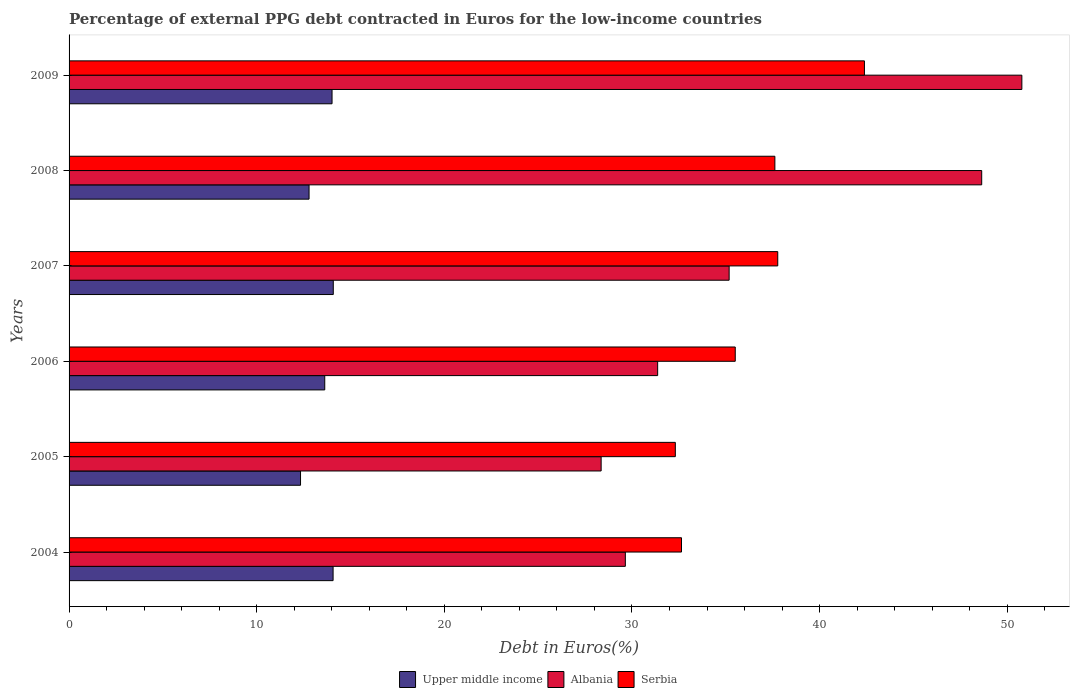Are the number of bars per tick equal to the number of legend labels?
Give a very brief answer. Yes. How many bars are there on the 4th tick from the top?
Your answer should be very brief. 3. What is the label of the 1st group of bars from the top?
Your answer should be compact. 2009. In how many cases, is the number of bars for a given year not equal to the number of legend labels?
Ensure brevity in your answer.  0. What is the percentage of external PPG debt contracted in Euros in Serbia in 2006?
Ensure brevity in your answer.  35.5. Across all years, what is the maximum percentage of external PPG debt contracted in Euros in Upper middle income?
Your answer should be compact. 14.08. Across all years, what is the minimum percentage of external PPG debt contracted in Euros in Albania?
Ensure brevity in your answer.  28.36. What is the total percentage of external PPG debt contracted in Euros in Serbia in the graph?
Provide a short and direct response. 218.23. What is the difference between the percentage of external PPG debt contracted in Euros in Serbia in 2006 and that in 2009?
Make the answer very short. -6.88. What is the difference between the percentage of external PPG debt contracted in Euros in Serbia in 2004 and the percentage of external PPG debt contracted in Euros in Albania in 2009?
Offer a terse response. -18.14. What is the average percentage of external PPG debt contracted in Euros in Upper middle income per year?
Provide a succinct answer. 13.49. In the year 2007, what is the difference between the percentage of external PPG debt contracted in Euros in Upper middle income and percentage of external PPG debt contracted in Euros in Serbia?
Give a very brief answer. -23.69. What is the ratio of the percentage of external PPG debt contracted in Euros in Albania in 2005 to that in 2009?
Provide a succinct answer. 0.56. Is the percentage of external PPG debt contracted in Euros in Upper middle income in 2005 less than that in 2006?
Your response must be concise. Yes. Is the difference between the percentage of external PPG debt contracted in Euros in Upper middle income in 2004 and 2009 greater than the difference between the percentage of external PPG debt contracted in Euros in Serbia in 2004 and 2009?
Offer a very short reply. Yes. What is the difference between the highest and the second highest percentage of external PPG debt contracted in Euros in Serbia?
Your response must be concise. 4.62. What is the difference between the highest and the lowest percentage of external PPG debt contracted in Euros in Upper middle income?
Your answer should be compact. 1.74. Is the sum of the percentage of external PPG debt contracted in Euros in Serbia in 2004 and 2009 greater than the maximum percentage of external PPG debt contracted in Euros in Albania across all years?
Offer a terse response. Yes. What does the 1st bar from the top in 2005 represents?
Your answer should be very brief. Serbia. What does the 2nd bar from the bottom in 2009 represents?
Your answer should be very brief. Albania. How many years are there in the graph?
Give a very brief answer. 6. Does the graph contain any zero values?
Your answer should be very brief. No. Does the graph contain grids?
Give a very brief answer. No. What is the title of the graph?
Give a very brief answer. Percentage of external PPG debt contracted in Euros for the low-income countries. Does "Chad" appear as one of the legend labels in the graph?
Provide a succinct answer. No. What is the label or title of the X-axis?
Make the answer very short. Debt in Euros(%). What is the Debt in Euros(%) in Upper middle income in 2004?
Your answer should be very brief. 14.07. What is the Debt in Euros(%) of Albania in 2004?
Provide a succinct answer. 29.65. What is the Debt in Euros(%) in Serbia in 2004?
Your response must be concise. 32.64. What is the Debt in Euros(%) of Upper middle income in 2005?
Offer a very short reply. 12.34. What is the Debt in Euros(%) of Albania in 2005?
Offer a terse response. 28.36. What is the Debt in Euros(%) in Serbia in 2005?
Your answer should be very brief. 32.31. What is the Debt in Euros(%) of Upper middle income in 2006?
Provide a short and direct response. 13.63. What is the Debt in Euros(%) in Albania in 2006?
Offer a terse response. 31.37. What is the Debt in Euros(%) in Serbia in 2006?
Your answer should be very brief. 35.5. What is the Debt in Euros(%) in Upper middle income in 2007?
Offer a terse response. 14.08. What is the Debt in Euros(%) in Albania in 2007?
Ensure brevity in your answer.  35.18. What is the Debt in Euros(%) of Serbia in 2007?
Provide a short and direct response. 37.77. What is the Debt in Euros(%) in Upper middle income in 2008?
Give a very brief answer. 12.79. What is the Debt in Euros(%) of Albania in 2008?
Offer a very short reply. 48.64. What is the Debt in Euros(%) in Serbia in 2008?
Provide a succinct answer. 37.62. What is the Debt in Euros(%) in Upper middle income in 2009?
Offer a terse response. 14.02. What is the Debt in Euros(%) in Albania in 2009?
Ensure brevity in your answer.  50.78. What is the Debt in Euros(%) in Serbia in 2009?
Make the answer very short. 42.39. Across all years, what is the maximum Debt in Euros(%) of Upper middle income?
Offer a terse response. 14.08. Across all years, what is the maximum Debt in Euros(%) of Albania?
Give a very brief answer. 50.78. Across all years, what is the maximum Debt in Euros(%) of Serbia?
Your response must be concise. 42.39. Across all years, what is the minimum Debt in Euros(%) in Upper middle income?
Make the answer very short. 12.34. Across all years, what is the minimum Debt in Euros(%) in Albania?
Provide a short and direct response. 28.36. Across all years, what is the minimum Debt in Euros(%) in Serbia?
Your answer should be very brief. 32.31. What is the total Debt in Euros(%) of Upper middle income in the graph?
Your response must be concise. 80.92. What is the total Debt in Euros(%) in Albania in the graph?
Give a very brief answer. 223.97. What is the total Debt in Euros(%) in Serbia in the graph?
Your answer should be compact. 218.23. What is the difference between the Debt in Euros(%) of Upper middle income in 2004 and that in 2005?
Make the answer very short. 1.74. What is the difference between the Debt in Euros(%) in Albania in 2004 and that in 2005?
Give a very brief answer. 1.29. What is the difference between the Debt in Euros(%) of Serbia in 2004 and that in 2005?
Your answer should be compact. 0.33. What is the difference between the Debt in Euros(%) in Upper middle income in 2004 and that in 2006?
Provide a short and direct response. 0.44. What is the difference between the Debt in Euros(%) in Albania in 2004 and that in 2006?
Your answer should be compact. -1.72. What is the difference between the Debt in Euros(%) in Serbia in 2004 and that in 2006?
Ensure brevity in your answer.  -2.86. What is the difference between the Debt in Euros(%) in Upper middle income in 2004 and that in 2007?
Make the answer very short. -0.01. What is the difference between the Debt in Euros(%) of Albania in 2004 and that in 2007?
Your response must be concise. -5.53. What is the difference between the Debt in Euros(%) of Serbia in 2004 and that in 2007?
Offer a terse response. -5.13. What is the difference between the Debt in Euros(%) in Upper middle income in 2004 and that in 2008?
Your answer should be very brief. 1.28. What is the difference between the Debt in Euros(%) in Albania in 2004 and that in 2008?
Your answer should be very brief. -18.99. What is the difference between the Debt in Euros(%) in Serbia in 2004 and that in 2008?
Offer a very short reply. -4.98. What is the difference between the Debt in Euros(%) of Upper middle income in 2004 and that in 2009?
Your answer should be compact. 0.06. What is the difference between the Debt in Euros(%) in Albania in 2004 and that in 2009?
Offer a terse response. -21.13. What is the difference between the Debt in Euros(%) of Serbia in 2004 and that in 2009?
Offer a very short reply. -9.75. What is the difference between the Debt in Euros(%) of Upper middle income in 2005 and that in 2006?
Provide a short and direct response. -1.29. What is the difference between the Debt in Euros(%) of Albania in 2005 and that in 2006?
Your answer should be very brief. -3.01. What is the difference between the Debt in Euros(%) in Serbia in 2005 and that in 2006?
Provide a short and direct response. -3.19. What is the difference between the Debt in Euros(%) in Upper middle income in 2005 and that in 2007?
Provide a short and direct response. -1.74. What is the difference between the Debt in Euros(%) of Albania in 2005 and that in 2007?
Keep it short and to the point. -6.82. What is the difference between the Debt in Euros(%) of Serbia in 2005 and that in 2007?
Your answer should be very brief. -5.46. What is the difference between the Debt in Euros(%) of Upper middle income in 2005 and that in 2008?
Your response must be concise. -0.45. What is the difference between the Debt in Euros(%) of Albania in 2005 and that in 2008?
Your answer should be compact. -20.28. What is the difference between the Debt in Euros(%) of Serbia in 2005 and that in 2008?
Ensure brevity in your answer.  -5.31. What is the difference between the Debt in Euros(%) in Upper middle income in 2005 and that in 2009?
Your answer should be very brief. -1.68. What is the difference between the Debt in Euros(%) of Albania in 2005 and that in 2009?
Your answer should be compact. -22.42. What is the difference between the Debt in Euros(%) of Serbia in 2005 and that in 2009?
Ensure brevity in your answer.  -10.08. What is the difference between the Debt in Euros(%) of Upper middle income in 2006 and that in 2007?
Offer a very short reply. -0.45. What is the difference between the Debt in Euros(%) of Albania in 2006 and that in 2007?
Keep it short and to the point. -3.81. What is the difference between the Debt in Euros(%) of Serbia in 2006 and that in 2007?
Offer a very short reply. -2.27. What is the difference between the Debt in Euros(%) of Upper middle income in 2006 and that in 2008?
Your answer should be compact. 0.84. What is the difference between the Debt in Euros(%) in Albania in 2006 and that in 2008?
Your response must be concise. -17.27. What is the difference between the Debt in Euros(%) in Serbia in 2006 and that in 2008?
Provide a succinct answer. -2.11. What is the difference between the Debt in Euros(%) of Upper middle income in 2006 and that in 2009?
Provide a succinct answer. -0.39. What is the difference between the Debt in Euros(%) in Albania in 2006 and that in 2009?
Give a very brief answer. -19.41. What is the difference between the Debt in Euros(%) in Serbia in 2006 and that in 2009?
Your answer should be very brief. -6.88. What is the difference between the Debt in Euros(%) of Upper middle income in 2007 and that in 2008?
Your response must be concise. 1.29. What is the difference between the Debt in Euros(%) in Albania in 2007 and that in 2008?
Ensure brevity in your answer.  -13.46. What is the difference between the Debt in Euros(%) of Serbia in 2007 and that in 2008?
Make the answer very short. 0.15. What is the difference between the Debt in Euros(%) of Upper middle income in 2007 and that in 2009?
Ensure brevity in your answer.  0.07. What is the difference between the Debt in Euros(%) of Albania in 2007 and that in 2009?
Your answer should be very brief. -15.6. What is the difference between the Debt in Euros(%) in Serbia in 2007 and that in 2009?
Your response must be concise. -4.62. What is the difference between the Debt in Euros(%) in Upper middle income in 2008 and that in 2009?
Offer a terse response. -1.23. What is the difference between the Debt in Euros(%) in Albania in 2008 and that in 2009?
Your answer should be compact. -2.14. What is the difference between the Debt in Euros(%) of Serbia in 2008 and that in 2009?
Your answer should be compact. -4.77. What is the difference between the Debt in Euros(%) of Upper middle income in 2004 and the Debt in Euros(%) of Albania in 2005?
Your response must be concise. -14.29. What is the difference between the Debt in Euros(%) in Upper middle income in 2004 and the Debt in Euros(%) in Serbia in 2005?
Your response must be concise. -18.24. What is the difference between the Debt in Euros(%) of Albania in 2004 and the Debt in Euros(%) of Serbia in 2005?
Give a very brief answer. -2.66. What is the difference between the Debt in Euros(%) in Upper middle income in 2004 and the Debt in Euros(%) in Albania in 2006?
Give a very brief answer. -17.3. What is the difference between the Debt in Euros(%) of Upper middle income in 2004 and the Debt in Euros(%) of Serbia in 2006?
Provide a succinct answer. -21.43. What is the difference between the Debt in Euros(%) of Albania in 2004 and the Debt in Euros(%) of Serbia in 2006?
Make the answer very short. -5.86. What is the difference between the Debt in Euros(%) of Upper middle income in 2004 and the Debt in Euros(%) of Albania in 2007?
Your answer should be very brief. -21.11. What is the difference between the Debt in Euros(%) of Upper middle income in 2004 and the Debt in Euros(%) of Serbia in 2007?
Keep it short and to the point. -23.7. What is the difference between the Debt in Euros(%) in Albania in 2004 and the Debt in Euros(%) in Serbia in 2007?
Give a very brief answer. -8.12. What is the difference between the Debt in Euros(%) of Upper middle income in 2004 and the Debt in Euros(%) of Albania in 2008?
Provide a short and direct response. -34.57. What is the difference between the Debt in Euros(%) in Upper middle income in 2004 and the Debt in Euros(%) in Serbia in 2008?
Your answer should be compact. -23.55. What is the difference between the Debt in Euros(%) in Albania in 2004 and the Debt in Euros(%) in Serbia in 2008?
Give a very brief answer. -7.97. What is the difference between the Debt in Euros(%) of Upper middle income in 2004 and the Debt in Euros(%) of Albania in 2009?
Your answer should be very brief. -36.71. What is the difference between the Debt in Euros(%) in Upper middle income in 2004 and the Debt in Euros(%) in Serbia in 2009?
Keep it short and to the point. -28.32. What is the difference between the Debt in Euros(%) of Albania in 2004 and the Debt in Euros(%) of Serbia in 2009?
Your response must be concise. -12.74. What is the difference between the Debt in Euros(%) in Upper middle income in 2005 and the Debt in Euros(%) in Albania in 2006?
Your answer should be compact. -19.03. What is the difference between the Debt in Euros(%) in Upper middle income in 2005 and the Debt in Euros(%) in Serbia in 2006?
Make the answer very short. -23.17. What is the difference between the Debt in Euros(%) in Albania in 2005 and the Debt in Euros(%) in Serbia in 2006?
Provide a succinct answer. -7.15. What is the difference between the Debt in Euros(%) in Upper middle income in 2005 and the Debt in Euros(%) in Albania in 2007?
Offer a very short reply. -22.84. What is the difference between the Debt in Euros(%) of Upper middle income in 2005 and the Debt in Euros(%) of Serbia in 2007?
Your answer should be compact. -25.43. What is the difference between the Debt in Euros(%) in Albania in 2005 and the Debt in Euros(%) in Serbia in 2007?
Provide a succinct answer. -9.41. What is the difference between the Debt in Euros(%) in Upper middle income in 2005 and the Debt in Euros(%) in Albania in 2008?
Provide a short and direct response. -36.3. What is the difference between the Debt in Euros(%) in Upper middle income in 2005 and the Debt in Euros(%) in Serbia in 2008?
Give a very brief answer. -25.28. What is the difference between the Debt in Euros(%) in Albania in 2005 and the Debt in Euros(%) in Serbia in 2008?
Provide a succinct answer. -9.26. What is the difference between the Debt in Euros(%) in Upper middle income in 2005 and the Debt in Euros(%) in Albania in 2009?
Make the answer very short. -38.44. What is the difference between the Debt in Euros(%) of Upper middle income in 2005 and the Debt in Euros(%) of Serbia in 2009?
Your answer should be very brief. -30.05. What is the difference between the Debt in Euros(%) of Albania in 2005 and the Debt in Euros(%) of Serbia in 2009?
Keep it short and to the point. -14.03. What is the difference between the Debt in Euros(%) of Upper middle income in 2006 and the Debt in Euros(%) of Albania in 2007?
Make the answer very short. -21.55. What is the difference between the Debt in Euros(%) of Upper middle income in 2006 and the Debt in Euros(%) of Serbia in 2007?
Your response must be concise. -24.14. What is the difference between the Debt in Euros(%) of Albania in 2006 and the Debt in Euros(%) of Serbia in 2007?
Offer a terse response. -6.4. What is the difference between the Debt in Euros(%) in Upper middle income in 2006 and the Debt in Euros(%) in Albania in 2008?
Ensure brevity in your answer.  -35.01. What is the difference between the Debt in Euros(%) in Upper middle income in 2006 and the Debt in Euros(%) in Serbia in 2008?
Give a very brief answer. -23.99. What is the difference between the Debt in Euros(%) in Albania in 2006 and the Debt in Euros(%) in Serbia in 2008?
Provide a short and direct response. -6.25. What is the difference between the Debt in Euros(%) of Upper middle income in 2006 and the Debt in Euros(%) of Albania in 2009?
Your response must be concise. -37.15. What is the difference between the Debt in Euros(%) of Upper middle income in 2006 and the Debt in Euros(%) of Serbia in 2009?
Provide a succinct answer. -28.76. What is the difference between the Debt in Euros(%) of Albania in 2006 and the Debt in Euros(%) of Serbia in 2009?
Your response must be concise. -11.02. What is the difference between the Debt in Euros(%) in Upper middle income in 2007 and the Debt in Euros(%) in Albania in 2008?
Keep it short and to the point. -34.56. What is the difference between the Debt in Euros(%) of Upper middle income in 2007 and the Debt in Euros(%) of Serbia in 2008?
Provide a short and direct response. -23.54. What is the difference between the Debt in Euros(%) of Albania in 2007 and the Debt in Euros(%) of Serbia in 2008?
Offer a very short reply. -2.44. What is the difference between the Debt in Euros(%) in Upper middle income in 2007 and the Debt in Euros(%) in Albania in 2009?
Provide a short and direct response. -36.7. What is the difference between the Debt in Euros(%) in Upper middle income in 2007 and the Debt in Euros(%) in Serbia in 2009?
Give a very brief answer. -28.31. What is the difference between the Debt in Euros(%) of Albania in 2007 and the Debt in Euros(%) of Serbia in 2009?
Offer a very short reply. -7.21. What is the difference between the Debt in Euros(%) in Upper middle income in 2008 and the Debt in Euros(%) in Albania in 2009?
Your answer should be compact. -37.99. What is the difference between the Debt in Euros(%) of Upper middle income in 2008 and the Debt in Euros(%) of Serbia in 2009?
Keep it short and to the point. -29.6. What is the difference between the Debt in Euros(%) of Albania in 2008 and the Debt in Euros(%) of Serbia in 2009?
Give a very brief answer. 6.25. What is the average Debt in Euros(%) in Upper middle income per year?
Provide a succinct answer. 13.49. What is the average Debt in Euros(%) of Albania per year?
Offer a very short reply. 37.33. What is the average Debt in Euros(%) of Serbia per year?
Keep it short and to the point. 36.37. In the year 2004, what is the difference between the Debt in Euros(%) in Upper middle income and Debt in Euros(%) in Albania?
Offer a very short reply. -15.58. In the year 2004, what is the difference between the Debt in Euros(%) of Upper middle income and Debt in Euros(%) of Serbia?
Give a very brief answer. -18.57. In the year 2004, what is the difference between the Debt in Euros(%) of Albania and Debt in Euros(%) of Serbia?
Offer a very short reply. -2.99. In the year 2005, what is the difference between the Debt in Euros(%) of Upper middle income and Debt in Euros(%) of Albania?
Provide a succinct answer. -16.02. In the year 2005, what is the difference between the Debt in Euros(%) in Upper middle income and Debt in Euros(%) in Serbia?
Your answer should be very brief. -19.98. In the year 2005, what is the difference between the Debt in Euros(%) of Albania and Debt in Euros(%) of Serbia?
Keep it short and to the point. -3.95. In the year 2006, what is the difference between the Debt in Euros(%) of Upper middle income and Debt in Euros(%) of Albania?
Ensure brevity in your answer.  -17.74. In the year 2006, what is the difference between the Debt in Euros(%) of Upper middle income and Debt in Euros(%) of Serbia?
Make the answer very short. -21.88. In the year 2006, what is the difference between the Debt in Euros(%) in Albania and Debt in Euros(%) in Serbia?
Provide a short and direct response. -4.14. In the year 2007, what is the difference between the Debt in Euros(%) of Upper middle income and Debt in Euros(%) of Albania?
Provide a short and direct response. -21.1. In the year 2007, what is the difference between the Debt in Euros(%) of Upper middle income and Debt in Euros(%) of Serbia?
Provide a short and direct response. -23.69. In the year 2007, what is the difference between the Debt in Euros(%) of Albania and Debt in Euros(%) of Serbia?
Offer a terse response. -2.59. In the year 2008, what is the difference between the Debt in Euros(%) of Upper middle income and Debt in Euros(%) of Albania?
Offer a very short reply. -35.85. In the year 2008, what is the difference between the Debt in Euros(%) of Upper middle income and Debt in Euros(%) of Serbia?
Give a very brief answer. -24.83. In the year 2008, what is the difference between the Debt in Euros(%) in Albania and Debt in Euros(%) in Serbia?
Make the answer very short. 11.02. In the year 2009, what is the difference between the Debt in Euros(%) of Upper middle income and Debt in Euros(%) of Albania?
Offer a very short reply. -36.76. In the year 2009, what is the difference between the Debt in Euros(%) of Upper middle income and Debt in Euros(%) of Serbia?
Make the answer very short. -28.37. In the year 2009, what is the difference between the Debt in Euros(%) of Albania and Debt in Euros(%) of Serbia?
Your answer should be compact. 8.39. What is the ratio of the Debt in Euros(%) in Upper middle income in 2004 to that in 2005?
Your answer should be very brief. 1.14. What is the ratio of the Debt in Euros(%) in Albania in 2004 to that in 2005?
Your response must be concise. 1.05. What is the ratio of the Debt in Euros(%) of Serbia in 2004 to that in 2005?
Your answer should be compact. 1.01. What is the ratio of the Debt in Euros(%) of Upper middle income in 2004 to that in 2006?
Ensure brevity in your answer.  1.03. What is the ratio of the Debt in Euros(%) in Albania in 2004 to that in 2006?
Your answer should be very brief. 0.95. What is the ratio of the Debt in Euros(%) in Serbia in 2004 to that in 2006?
Offer a terse response. 0.92. What is the ratio of the Debt in Euros(%) of Upper middle income in 2004 to that in 2007?
Make the answer very short. 1. What is the ratio of the Debt in Euros(%) in Albania in 2004 to that in 2007?
Give a very brief answer. 0.84. What is the ratio of the Debt in Euros(%) of Serbia in 2004 to that in 2007?
Offer a terse response. 0.86. What is the ratio of the Debt in Euros(%) in Upper middle income in 2004 to that in 2008?
Keep it short and to the point. 1.1. What is the ratio of the Debt in Euros(%) in Albania in 2004 to that in 2008?
Offer a very short reply. 0.61. What is the ratio of the Debt in Euros(%) of Serbia in 2004 to that in 2008?
Give a very brief answer. 0.87. What is the ratio of the Debt in Euros(%) in Albania in 2004 to that in 2009?
Your response must be concise. 0.58. What is the ratio of the Debt in Euros(%) of Serbia in 2004 to that in 2009?
Give a very brief answer. 0.77. What is the ratio of the Debt in Euros(%) in Upper middle income in 2005 to that in 2006?
Give a very brief answer. 0.91. What is the ratio of the Debt in Euros(%) of Albania in 2005 to that in 2006?
Make the answer very short. 0.9. What is the ratio of the Debt in Euros(%) of Serbia in 2005 to that in 2006?
Your answer should be very brief. 0.91. What is the ratio of the Debt in Euros(%) of Upper middle income in 2005 to that in 2007?
Offer a very short reply. 0.88. What is the ratio of the Debt in Euros(%) in Albania in 2005 to that in 2007?
Give a very brief answer. 0.81. What is the ratio of the Debt in Euros(%) in Serbia in 2005 to that in 2007?
Offer a very short reply. 0.86. What is the ratio of the Debt in Euros(%) in Upper middle income in 2005 to that in 2008?
Keep it short and to the point. 0.96. What is the ratio of the Debt in Euros(%) of Albania in 2005 to that in 2008?
Keep it short and to the point. 0.58. What is the ratio of the Debt in Euros(%) of Serbia in 2005 to that in 2008?
Ensure brevity in your answer.  0.86. What is the ratio of the Debt in Euros(%) in Upper middle income in 2005 to that in 2009?
Your answer should be compact. 0.88. What is the ratio of the Debt in Euros(%) in Albania in 2005 to that in 2009?
Give a very brief answer. 0.56. What is the ratio of the Debt in Euros(%) in Serbia in 2005 to that in 2009?
Your answer should be compact. 0.76. What is the ratio of the Debt in Euros(%) in Albania in 2006 to that in 2007?
Provide a succinct answer. 0.89. What is the ratio of the Debt in Euros(%) of Upper middle income in 2006 to that in 2008?
Your answer should be very brief. 1.07. What is the ratio of the Debt in Euros(%) in Albania in 2006 to that in 2008?
Give a very brief answer. 0.64. What is the ratio of the Debt in Euros(%) of Serbia in 2006 to that in 2008?
Keep it short and to the point. 0.94. What is the ratio of the Debt in Euros(%) of Upper middle income in 2006 to that in 2009?
Provide a succinct answer. 0.97. What is the ratio of the Debt in Euros(%) in Albania in 2006 to that in 2009?
Your response must be concise. 0.62. What is the ratio of the Debt in Euros(%) in Serbia in 2006 to that in 2009?
Ensure brevity in your answer.  0.84. What is the ratio of the Debt in Euros(%) of Upper middle income in 2007 to that in 2008?
Provide a succinct answer. 1.1. What is the ratio of the Debt in Euros(%) in Albania in 2007 to that in 2008?
Your response must be concise. 0.72. What is the ratio of the Debt in Euros(%) of Serbia in 2007 to that in 2008?
Give a very brief answer. 1. What is the ratio of the Debt in Euros(%) in Albania in 2007 to that in 2009?
Ensure brevity in your answer.  0.69. What is the ratio of the Debt in Euros(%) in Serbia in 2007 to that in 2009?
Offer a terse response. 0.89. What is the ratio of the Debt in Euros(%) in Upper middle income in 2008 to that in 2009?
Provide a short and direct response. 0.91. What is the ratio of the Debt in Euros(%) of Albania in 2008 to that in 2009?
Your answer should be compact. 0.96. What is the ratio of the Debt in Euros(%) in Serbia in 2008 to that in 2009?
Provide a succinct answer. 0.89. What is the difference between the highest and the second highest Debt in Euros(%) in Upper middle income?
Offer a terse response. 0.01. What is the difference between the highest and the second highest Debt in Euros(%) of Albania?
Your response must be concise. 2.14. What is the difference between the highest and the second highest Debt in Euros(%) of Serbia?
Offer a very short reply. 4.62. What is the difference between the highest and the lowest Debt in Euros(%) in Upper middle income?
Your response must be concise. 1.74. What is the difference between the highest and the lowest Debt in Euros(%) of Albania?
Keep it short and to the point. 22.42. What is the difference between the highest and the lowest Debt in Euros(%) of Serbia?
Keep it short and to the point. 10.08. 